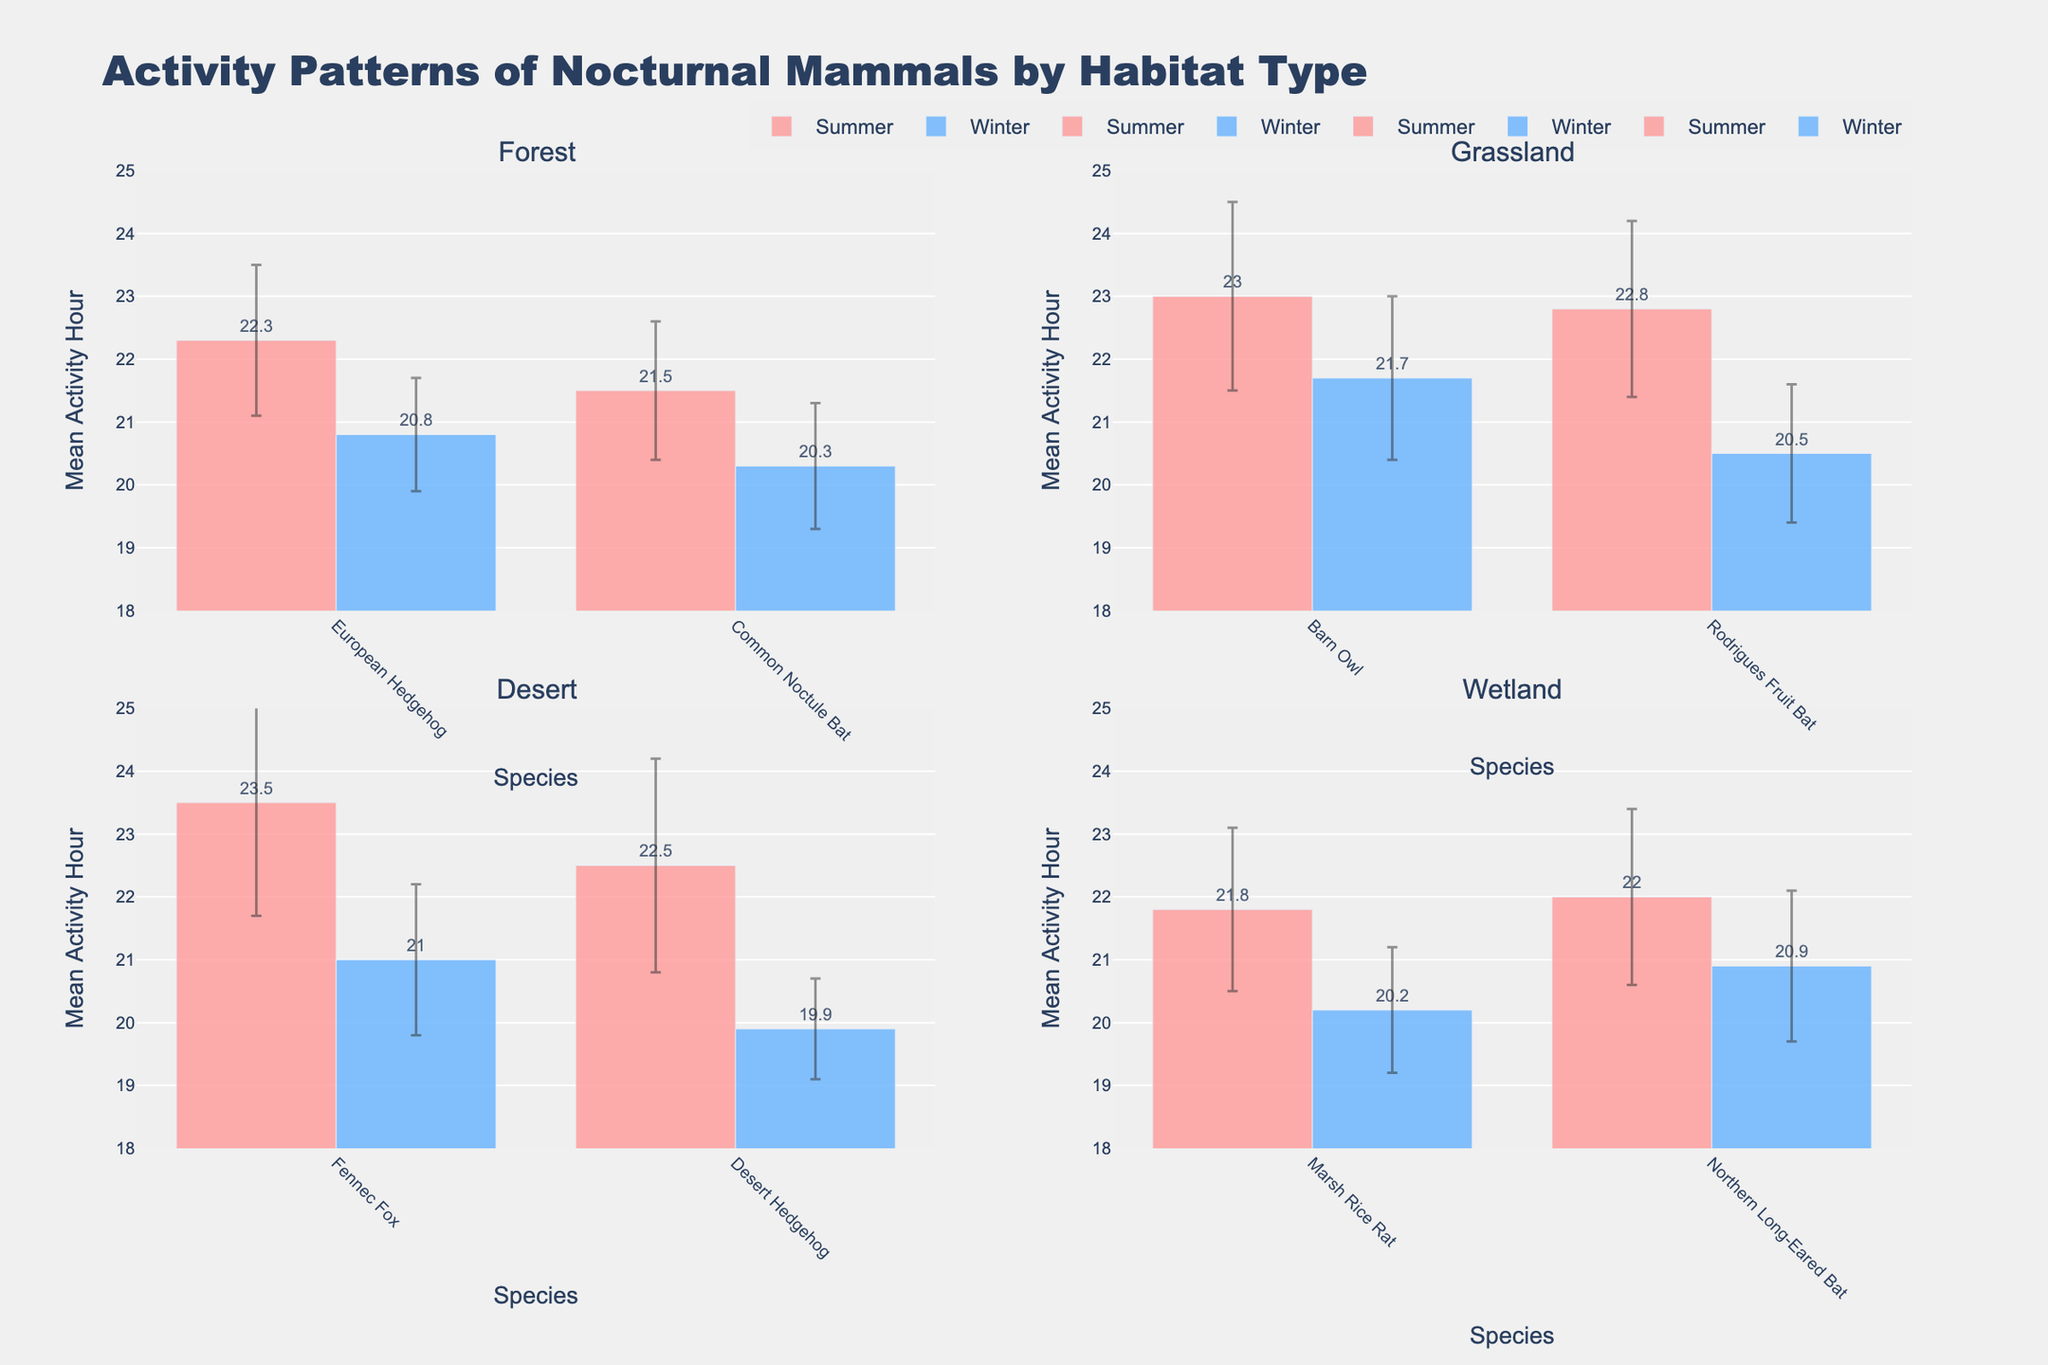What is the title of the figure? The title of the figure is prominently shown at the top, indicating the overall subject matter.
Answer: Activity Patterns of Nocturnal Mammals by Habitat Type Which species has the highest mean activity hour in the Desert during Summer? The mean activity hours for species in the Desert during Summer are shown in the Desert subplot. The Fennec Fox has a mean activity hour of 23.5, which is the highest in that group.
Answer: Fennec Fox How does the mean activity hour of the European Hedgehog in the Forest during Summer compare to Winter? In the Forest subplot, the mean activity hour for the European Hedgehog is 22.3 in Summer and 20.8 in Winter. Comparing these, the activity hour is higher in the Summer.
Answer: Higher in Summer by 1.5 hours Which habitat shows the greatest variance in activity hours between Summer and Winter overall? By assessing the mean activity hour difference across all species within each habitat from Summer to Winter: Forest (1.5), Grassland (2.55), Desert (2.55), Wetland (0.95). Both Grassland and Desert have the greatest variance with a difference of 2.55 hours.
Answer: Grassland and Desert What are the error bar ranges for Barn Owl during Summer and Winter in Grassland? In the Grassland subplot under Barn Owl, the mean activity hour for Summer is 23.0 with a standard deviation of 1.5 and for Winter is 21.7 with a standard deviation of 1.3. The error bar range for Summer is [21.5, 24.5], and for Winter is [20.4, 23.0].
Answer: Summer: [21.5, 24.5], Winter: [20.4, 23.0] What is the average mean activity hour for the species in Wetland during Winter? The species in Wetland during Winter are Marsh Rice Rat with 20.2 and Northern Long-Eared Bat with 20.9. To find the average: (20.2 + 20.9) / 2 = 20.55.
Answer: 20.55 Which species in the subplot has the smallest standard deviation of activity hours? The standard deviations are shown with the error bars. The Desert Hedgehog in the Desert subplot during Winter has the smallest standard deviation of 0.8.
Answer: Desert Hedgehog in Winter How many species are displayed in each habitat subplot? Each subplot represents a different habitat, and within each subplot, the number of unique species' bars can be counted. There are 2 species in each subplot.
Answer: 2 species 